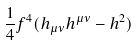<formula> <loc_0><loc_0><loc_500><loc_500>\frac { 1 } { 4 } f ^ { 4 } ( h _ { \mu \nu } h ^ { \mu \nu } - h ^ { 2 } )</formula> 